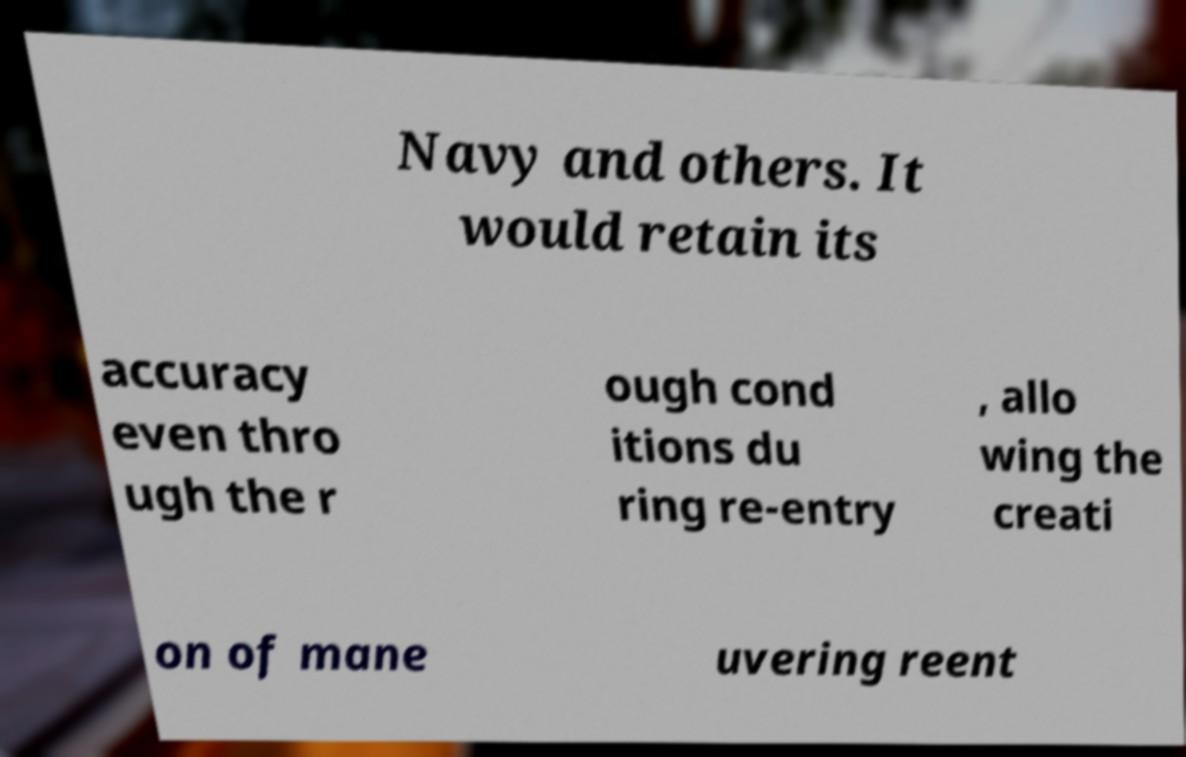Could you assist in decoding the text presented in this image and type it out clearly? Navy and others. It would retain its accuracy even thro ugh the r ough cond itions du ring re-entry , allo wing the creati on of mane uvering reent 